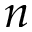Convert formula to latex. <formula><loc_0><loc_0><loc_500><loc_500>n</formula> 